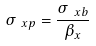Convert formula to latex. <formula><loc_0><loc_0><loc_500><loc_500>\sigma _ { \ x p } = \frac { \sigma _ { \ x b } } { \beta _ { x } }</formula> 